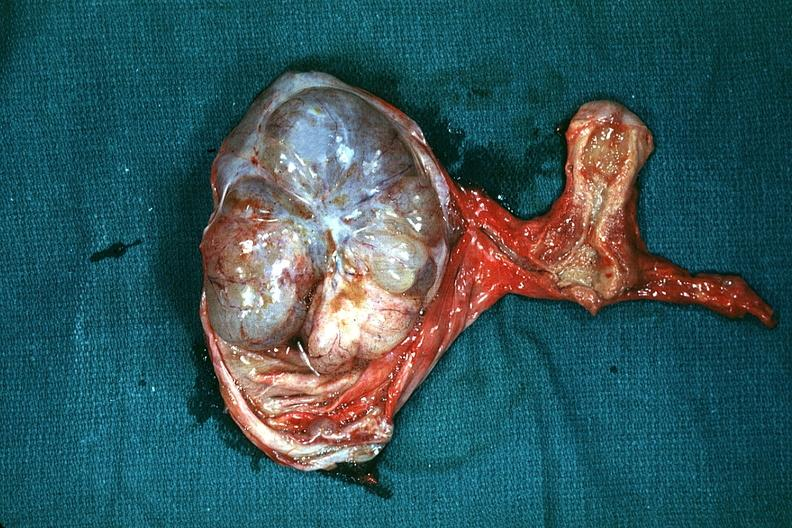what is the excellent uterus in and thus illustrates the very large size of the ovarian tumor?
Answer the question using a single word or phrase. In picture 